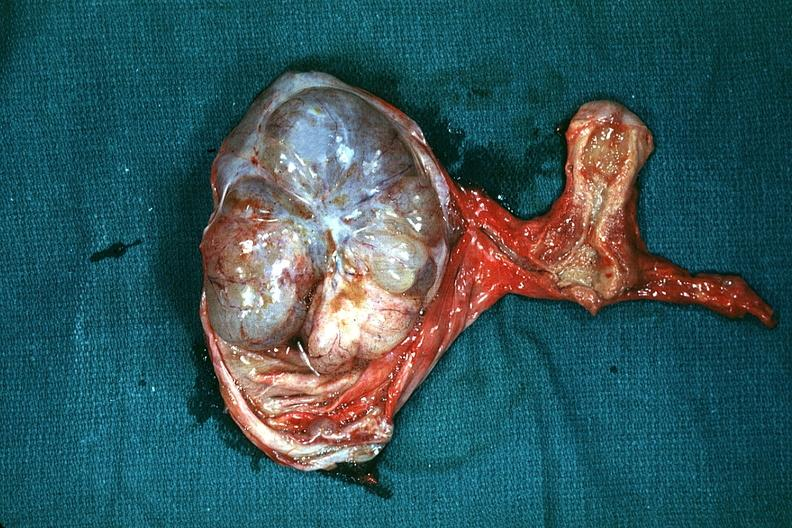what is the excellent uterus in and thus illustrates the very large size of the ovarian tumor?
Answer the question using a single word or phrase. In picture 